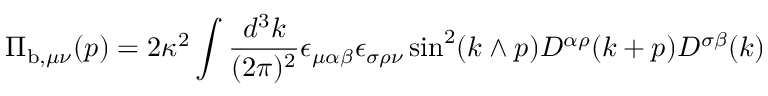Convert formula to latex. <formula><loc_0><loc_0><loc_500><loc_500>\Pi _ { b , \mu \nu } ( p ) = 2 \kappa ^ { 2 } \int \frac { d ^ { 3 } k } { ( 2 \pi ) ^ { 2 } } \epsilon _ { \mu \alpha \beta } \epsilon _ { \sigma \rho \nu } \sin ^ { 2 } ( k \wedge p ) D ^ { \alpha \rho } ( k + p ) D ^ { \sigma \beta } ( k )</formula> 